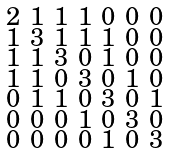Convert formula to latex. <formula><loc_0><loc_0><loc_500><loc_500>\begin{smallmatrix} 2 & 1 & 1 & 1 & 0 & 0 & 0 \\ 1 & 3 & 1 & 1 & 1 & 0 & 0 \\ 1 & 1 & 3 & 0 & 1 & 0 & 0 \\ 1 & 1 & 0 & 3 & 0 & 1 & 0 \\ 0 & 1 & 1 & 0 & 3 & 0 & 1 \\ 0 & 0 & 0 & 1 & 0 & 3 & 0 \\ 0 & 0 & 0 & 0 & 1 & 0 & 3 \end{smallmatrix}</formula> 